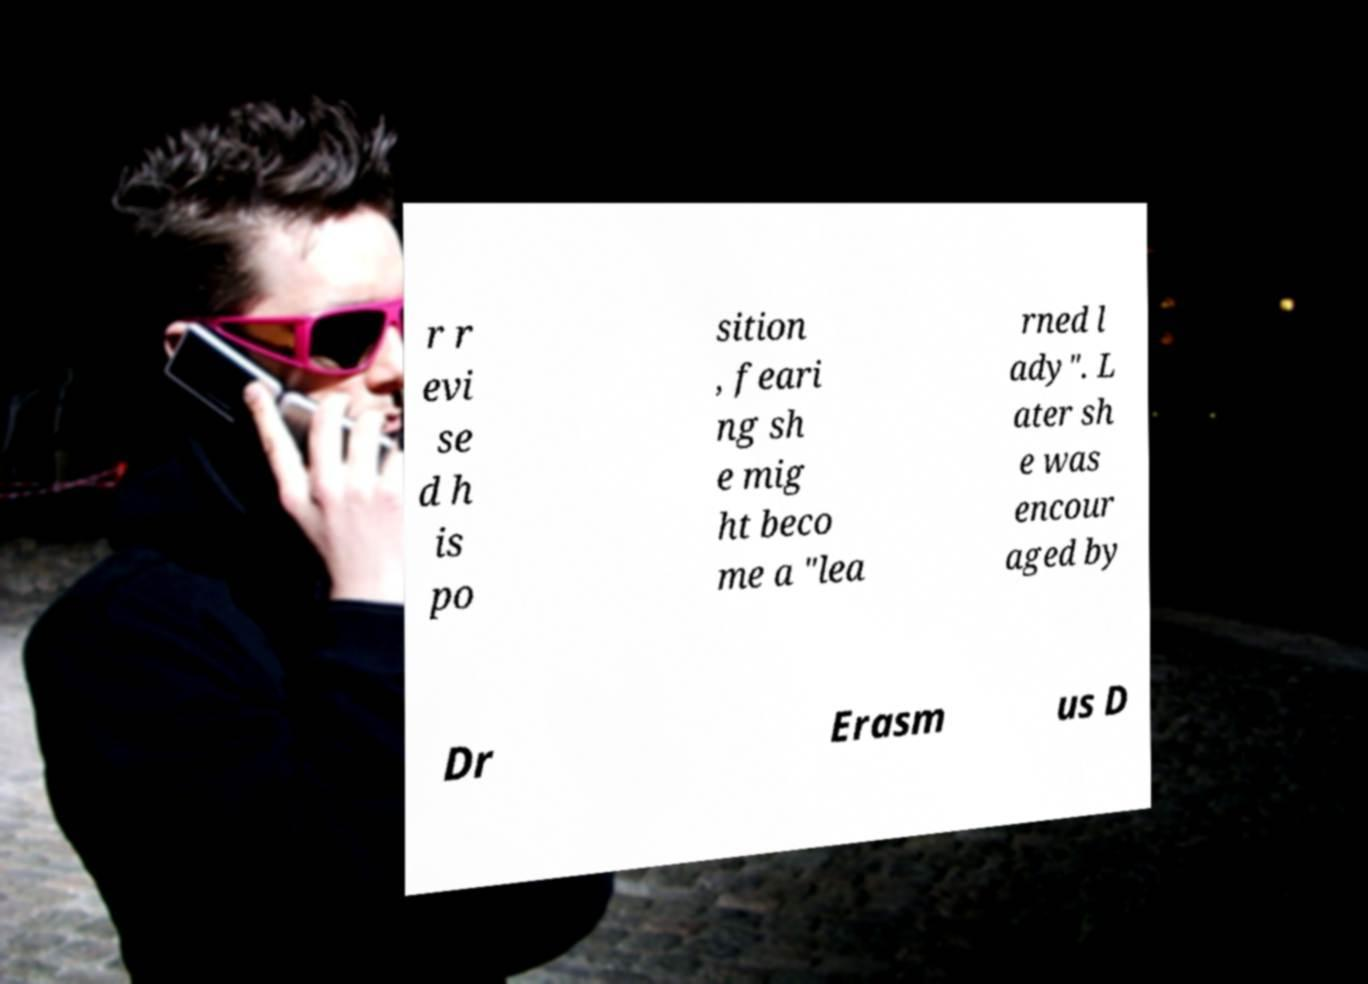Can you read and provide the text displayed in the image?This photo seems to have some interesting text. Can you extract and type it out for me? r r evi se d h is po sition , feari ng sh e mig ht beco me a "lea rned l ady". L ater sh e was encour aged by Dr Erasm us D 